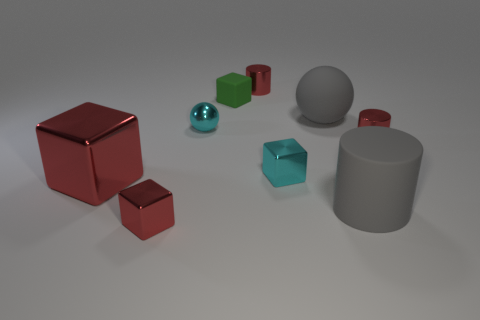Subtract all balls. How many objects are left? 7 Add 5 big rubber objects. How many big rubber objects exist? 7 Subtract 0 yellow balls. How many objects are left? 9 Subtract all tiny shiny things. Subtract all large matte cylinders. How many objects are left? 3 Add 6 tiny cyan shiny cubes. How many tiny cyan shiny cubes are left? 7 